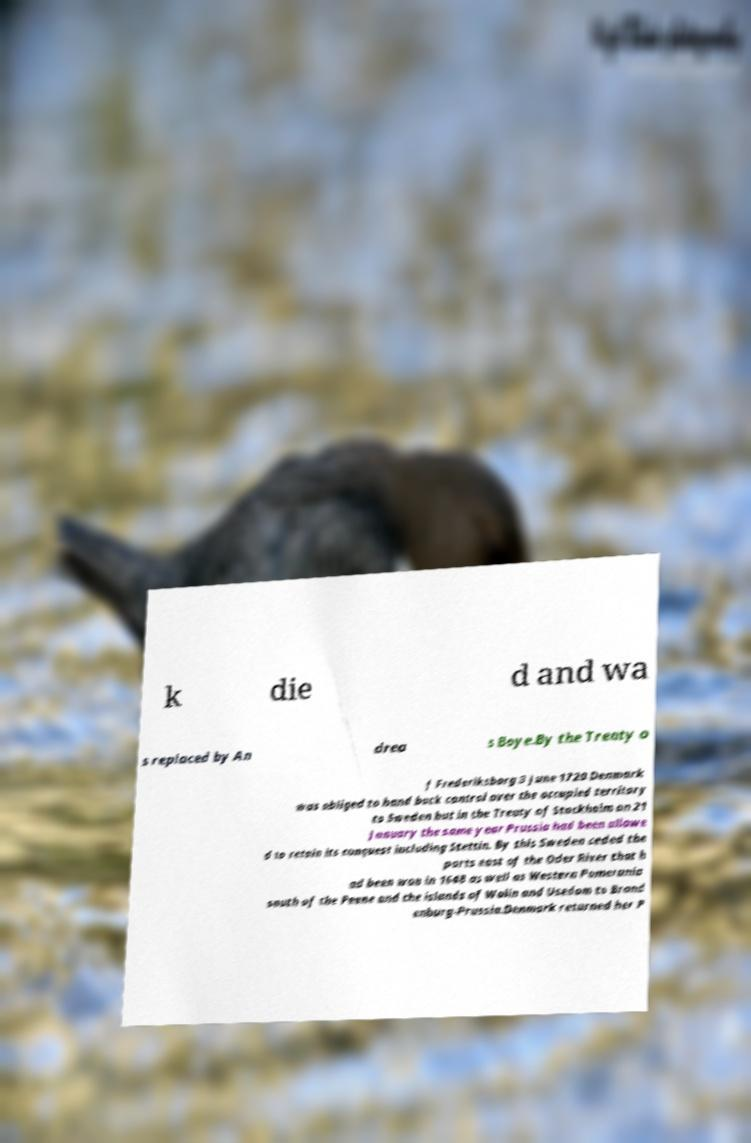Please read and relay the text visible in this image. What does it say? k die d and wa s replaced by An drea s Boye.By the Treaty o f Frederiksborg 3 June 1720 Denmark was obliged to hand back control over the occupied territory to Sweden but in the Treaty of Stockholm on 21 January the same year Prussia had been allowe d to retain its conquest including Stettin. By this Sweden ceded the parts east of the Oder River that h ad been won in 1648 as well as Western Pomerania south of the Peene and the islands of Wolin and Usedom to Brand enburg-Prussia.Denmark returned her P 